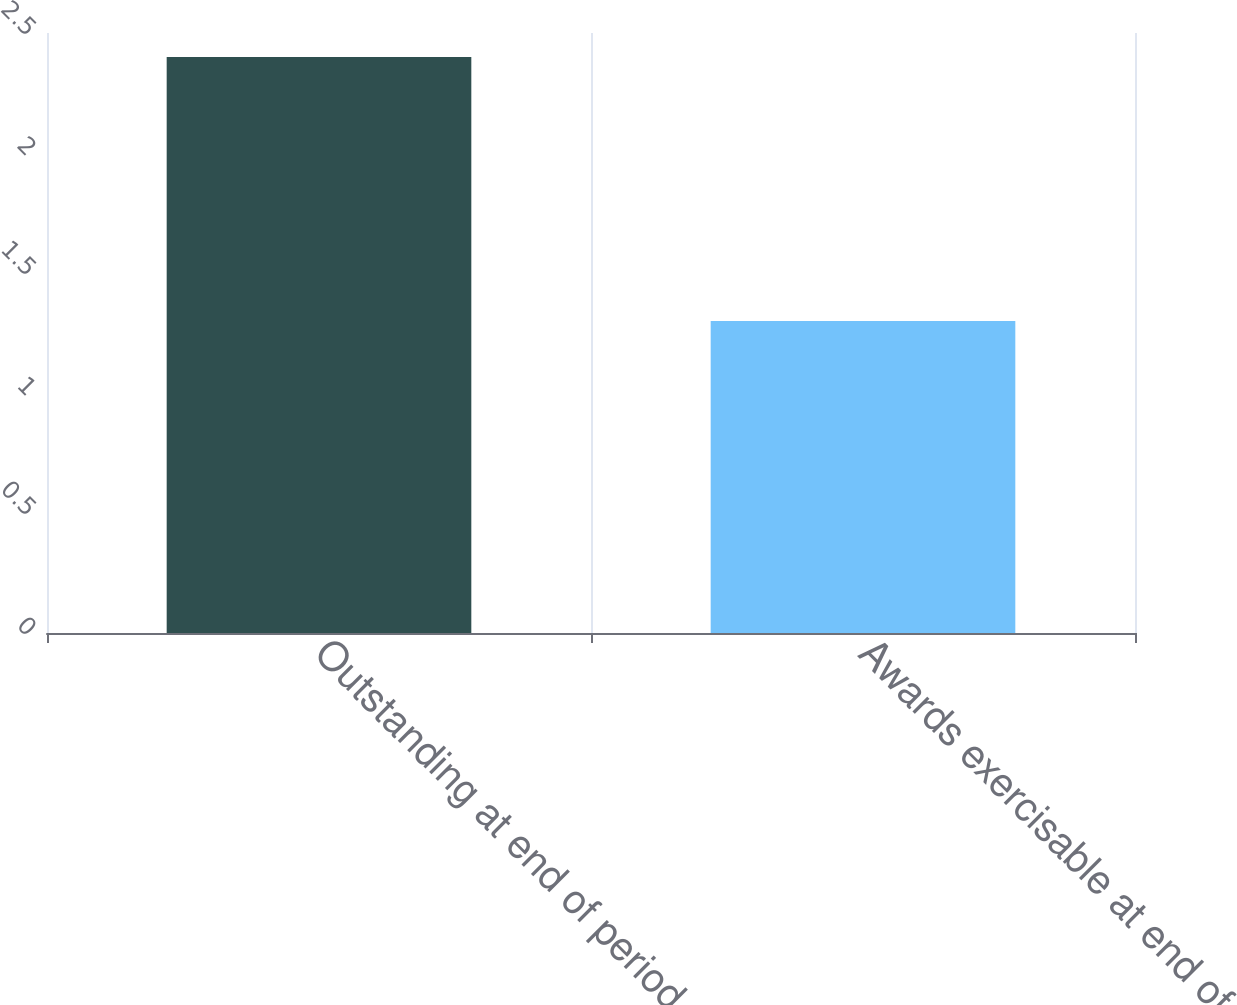<chart> <loc_0><loc_0><loc_500><loc_500><bar_chart><fcel>Outstanding at end of period<fcel>Awards exercisable at end of<nl><fcel>2.4<fcel>1.3<nl></chart> 